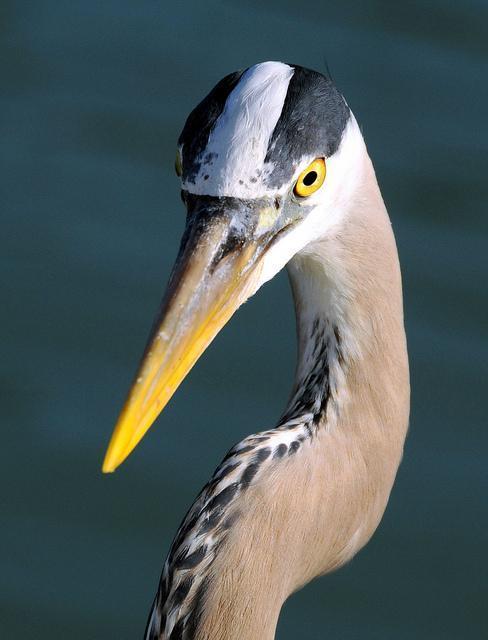How many birds are in the picture?
Give a very brief answer. 1. 